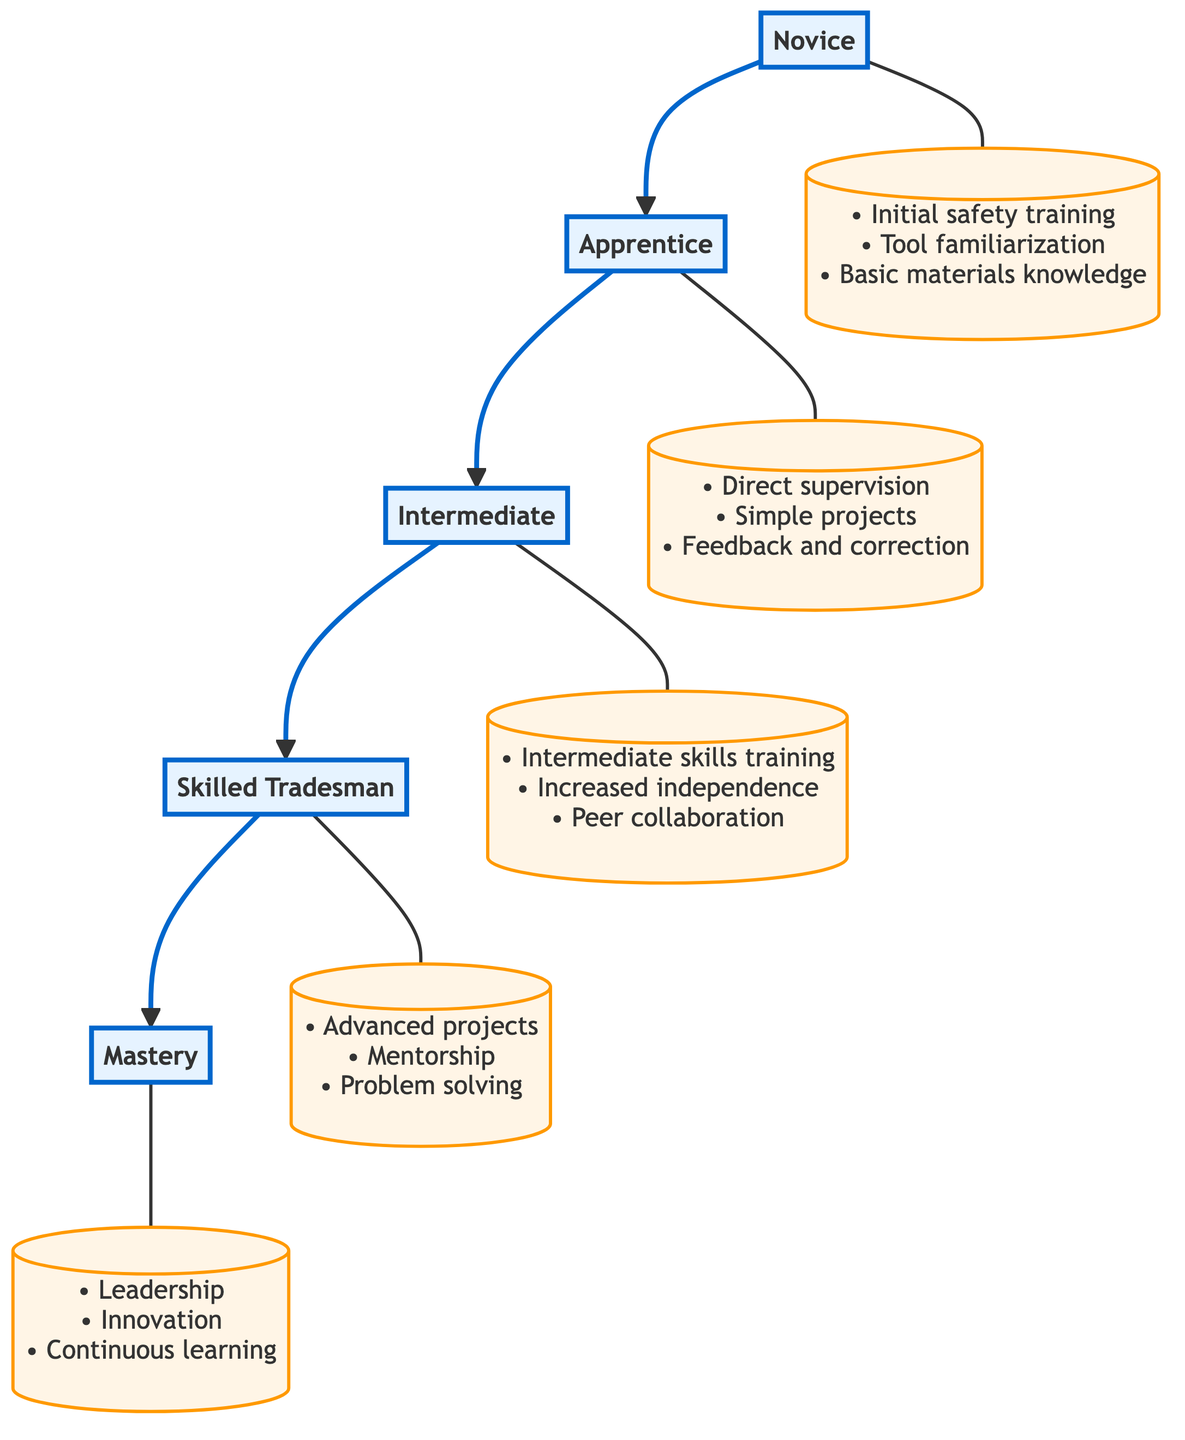What is the topmost level in the diagram? The topmost level of the flow chart is labeled "Mastery", which signifies the final stage of the apprenticeship progression. This can be identified as it is the furthest up in the flow of the diagram.
Answer: Mastery How many levels are there in the apprenticeship progression? Counting all the levels from the bottom (Novice) to the top (Mastery), there are a total of five distinct levels in the diagram.
Answer: 5 What key element is associated with the Skilled Tradesman level? The description of the Skilled Tradesman level lists "advanced projects" as one of its key elements, indicating a focus on managing and executing complex work independently.
Answer: Advanced projects Which level directly follows the Apprentice level? Based on the flow chart's structure, the level that directly follows Apprentice is the Intermediate level, as indicated by the upward arrow linking these two stages.
Answer: Intermediate What description is given for the Novice level? The Novice level is described as involving "initial instruction and basic orientation to tools and workspace safety," highlighting its foundational role in the learning process.
Answer: Initial instruction and basic orientation to tools and workspace safety What relationship exists between Intermediate and Skilled Tradesman levels? The relationship is sequential; Intermediate is directly below Skilled Tradesman in the flow chart, indicating that progression from Intermediate leads directly to becoming a Skilled Tradesman.
Answer: Intermediate leads to Skilled Tradesman What is the primary focus of the Mastery level? The primary focus of the Mastery level is on "complete mastery of trade techniques," emphasizing leadership, innovation, and continuous learning within the trade. This is evident from the level's description in the diagram.
Answer: Complete mastery of trade techniques What is one key component of the Apprentice level? One key component of the Apprentice level is "direct supervision," which emphasizes that apprentices work under the guidance of skilled tradesmen as part of their training.
Answer: Direct supervision How does peer collaboration relate to the Intermediate level? Peer collaboration is an element of the Intermediate level, indicating that learners work alongside their peers on medium complexity tasks, which aids in developing skills and building teamwork experience.
Answer: Peer collaboration 